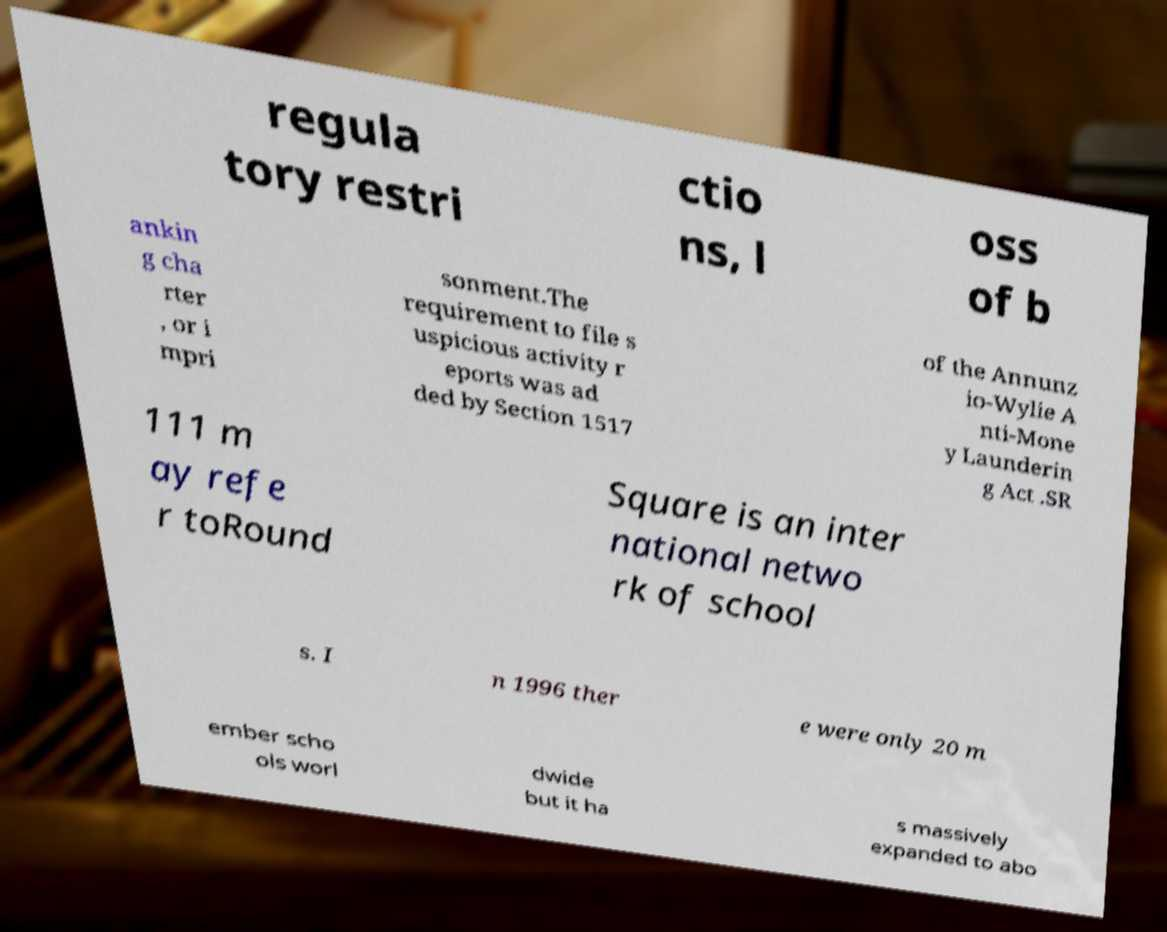Can you read and provide the text displayed in the image?This photo seems to have some interesting text. Can you extract and type it out for me? regula tory restri ctio ns, l oss of b ankin g cha rter , or i mpri sonment.The requirement to file s uspicious activity r eports was ad ded by Section 1517 of the Annunz io-Wylie A nti-Mone y Launderin g Act .SR 111 m ay refe r toRound Square is an inter national netwo rk of school s. I n 1996 ther e were only 20 m ember scho ols worl dwide but it ha s massively expanded to abo 